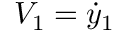<formula> <loc_0><loc_0><loc_500><loc_500>V _ { 1 } = \dot { y } _ { 1 }</formula> 